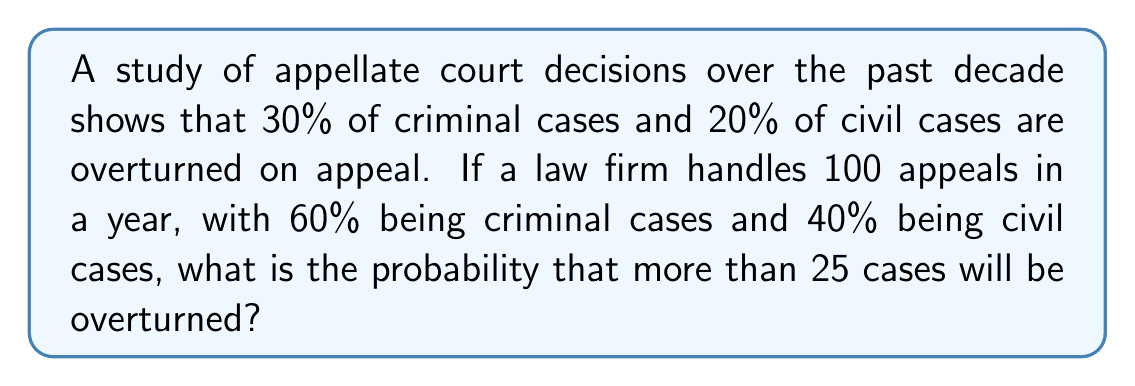Solve this math problem. Let's approach this step-by-step:

1) First, we need to calculate the overall probability of a case being overturned:
   For criminal cases: $0.60 \times 0.30 = 0.18$
   For civil cases: $0.40 \times 0.20 = 0.08$
   Total probability: $0.18 + 0.08 = 0.26$

2) This scenario follows a binomial distribution with:
   $n = 100$ (total number of cases)
   $p = 0.26$ (probability of success, i.e., case being overturned)

3) We need to find $P(X > 25)$, where $X$ is the number of overturned cases.

4) This is equivalent to $1 - P(X \leq 25)$

5) The probability mass function for a binomial distribution is:

   $$P(X = k) = \binom{n}{k} p^k (1-p)^{n-k}$$

6) We need to sum this for $k = 0$ to $25$:

   $$P(X \leq 25) = \sum_{k=0}^{25} \binom{100}{k} (0.26)^k (0.74)^{100-k}$$

7) This sum is complex to calculate by hand, so we'd typically use statistical software or a calculator with binomial distribution functions.

8) Using such a tool, we find that $P(X \leq 25) \approx 0.4013$

9) Therefore, $P(X > 25) = 1 - 0.4013 = 0.5987$
Answer: $0.5987$ or approximately $59.87\%$ 